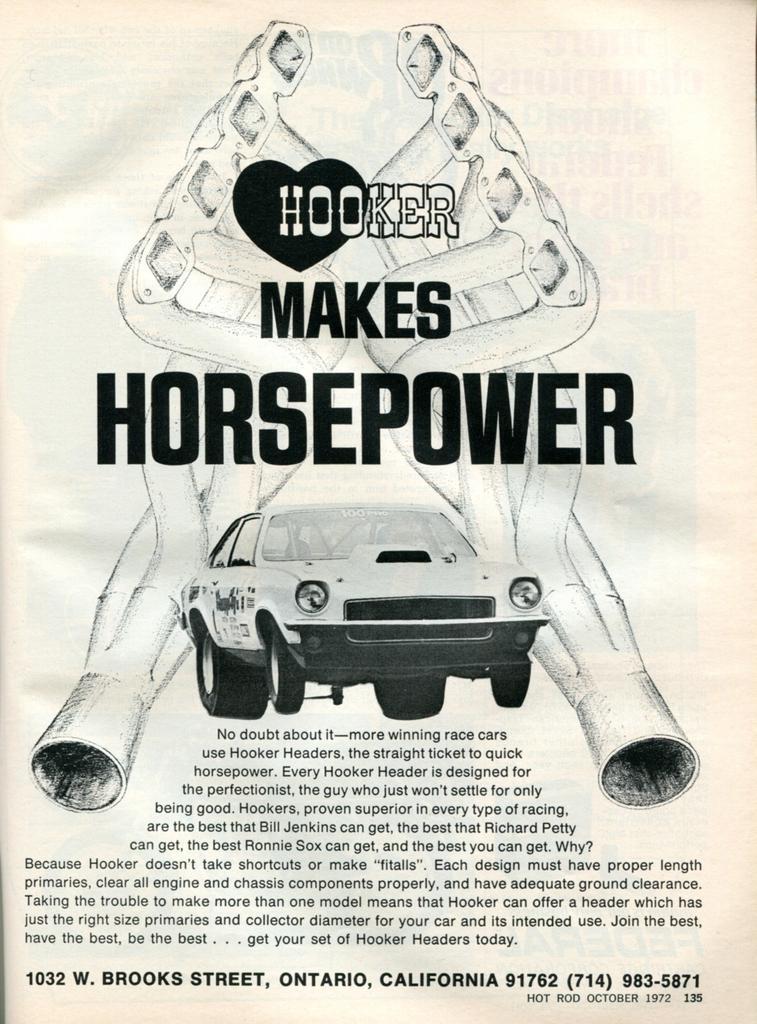Can you describe this image briefly? This is a poster having an animated image and black color texts. In the image, we can see there is a vehicle and there are two designs. And the background is white in color. 